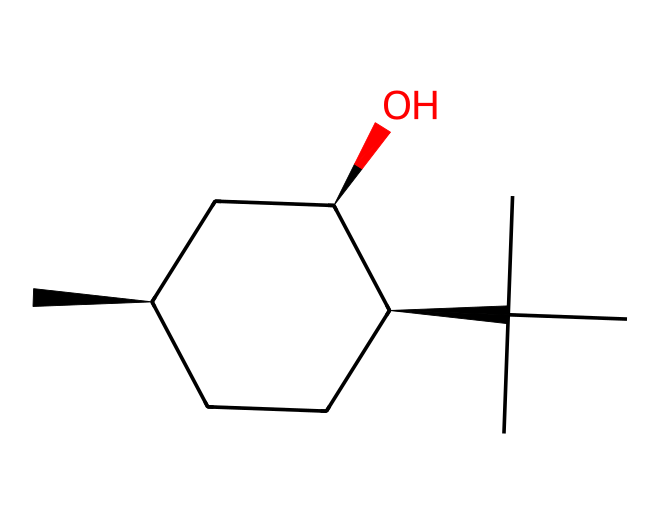What is the name of this chiral compound? The chemical structure corresponds to menthol, as it is widely recognized for its occurrence in peppermint and culinary uses.
Answer: menthol How many carbon atoms are in this chemical? Counting the carbon (C) atoms in the SMILES representation, there are ten carbon atoms in total.
Answer: 10 What type of functional group is present in menthol? The OH group indicates the presence of an alcohol functional group in menthol, defined by the -OH hydroxyl group in the structure.
Answer: alcohol How many chiral centers does menthol have? By analyzing the structure, there are three chiral centers as identified by the stereochemistry symbols (@ and @@) in the SMILES representation.
Answer: 3 What type of isomerism does menthol exhibit? Due to the presence of chiral centers, menthol exhibits optical isomerism, which occurs when compounds can rotate plane-polarized light differently.
Answer: optical Which atoms are responsible for the alcohol characteristic in menthol? The oxygen atom (O) in the hydroxyl (-OH) group is fundamental for identifying the alcohol characteristic in the structure of menthol.
Answer: oxygen What is the configuration of the first chiral center in menthol according to its SMILES? The configuration of the first chiral center is S (or counterclockwise), as indicated by the symbol @ in the structural notation of the SMILES.
Answer: S 